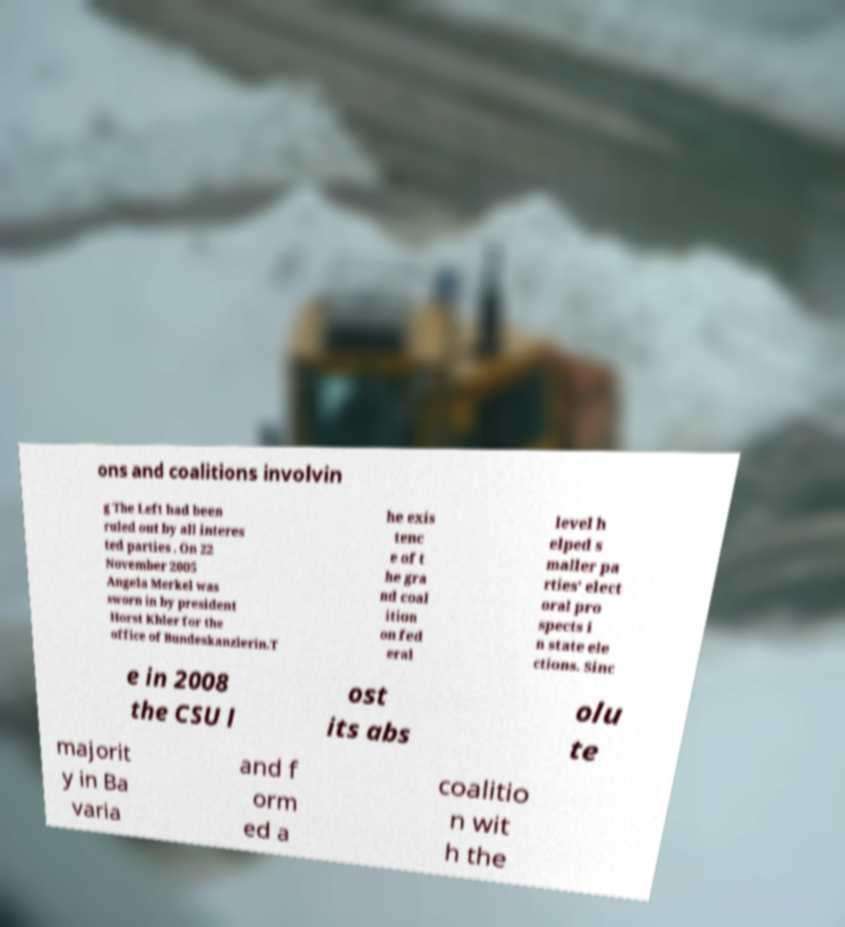Please identify and transcribe the text found in this image. ons and coalitions involvin g The Left had been ruled out by all interes ted parties . On 22 November 2005 Angela Merkel was sworn in by president Horst Khler for the office of Bundeskanzlerin.T he exis tenc e of t he gra nd coal ition on fed eral level h elped s maller pa rties' elect oral pro spects i n state ele ctions. Sinc e in 2008 the CSU l ost its abs olu te majorit y in Ba varia and f orm ed a coalitio n wit h the 